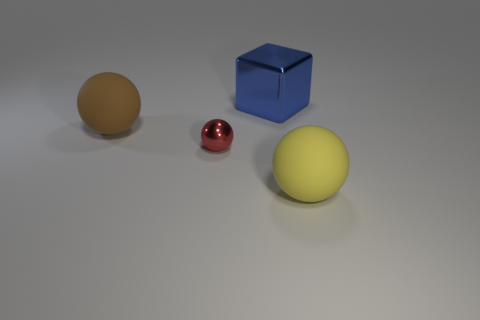How many objects are balls that are to the left of the large blue metal object or large blue shiny cubes?
Provide a succinct answer. 3. Is there another small object that has the same shape as the blue thing?
Provide a succinct answer. No. There is a metal thing that is the same size as the brown sphere; what is its shape?
Keep it short and to the point. Cube. There is a large matte object that is in front of the large matte object that is on the left side of the thing that is on the right side of the large blue block; what is its shape?
Give a very brief answer. Sphere. There is a blue object; is its shape the same as the rubber object in front of the tiny red shiny ball?
Offer a very short reply. No. What number of big things are brown matte balls or cyan shiny spheres?
Make the answer very short. 1. Is there a brown sphere of the same size as the blue block?
Your answer should be compact. Yes. The big sphere that is to the right of the rubber thing behind the big object in front of the large brown object is what color?
Ensure brevity in your answer.  Yellow. Is the material of the brown sphere the same as the sphere on the right side of the large metal thing?
Make the answer very short. Yes. What size is the red object that is the same shape as the big yellow rubber object?
Ensure brevity in your answer.  Small. 